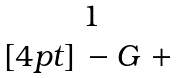<formula> <loc_0><loc_0><loc_500><loc_500>\begin{matrix} 1 \\ [ 4 p t ] \, - G ^ { \ } + \, \end{matrix}</formula> 